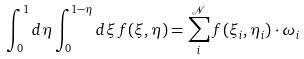<formula> <loc_0><loc_0><loc_500><loc_500>\int _ { 0 } ^ { 1 } d \eta \int _ { 0 } ^ { 1 - \eta } d \xi \, f ( \xi , \eta ) = \sum _ { i } ^ { \mathcal { N } } f ( \xi _ { i } , \eta _ { i } ) \cdot \omega _ { i }</formula> 